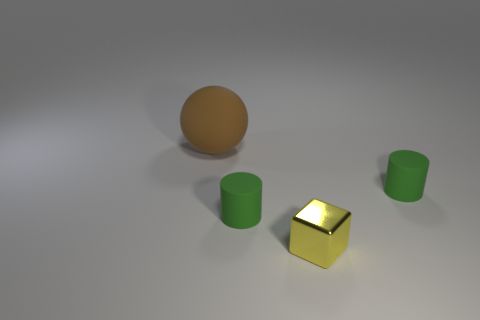Are there an equal number of green matte cylinders that are to the left of the small metallic object and tiny yellow cubes that are on the left side of the large rubber object?
Make the answer very short. No. Are there any yellow objects made of the same material as the small block?
Your answer should be compact. No. Is the material of the cylinder that is left of the tiny yellow block the same as the small yellow thing?
Your answer should be compact. No. There is a object that is in front of the big ball and left of the small yellow thing; what size is it?
Provide a succinct answer. Small. What is the color of the large matte ball?
Give a very brief answer. Brown. What number of tiny shiny things are there?
Provide a succinct answer. 1. What number of cylinders have the same color as the small shiny block?
Your response must be concise. 0. Is the shape of the small thing on the left side of the tiny yellow thing the same as the brown object that is to the left of the tiny shiny thing?
Provide a short and direct response. No. The matte thing that is on the left side of the green matte cylinder to the left of the small cylinder right of the tiny metal cube is what color?
Give a very brief answer. Brown. There is a small rubber thing that is to the right of the tiny yellow block; what color is it?
Provide a succinct answer. Green. 